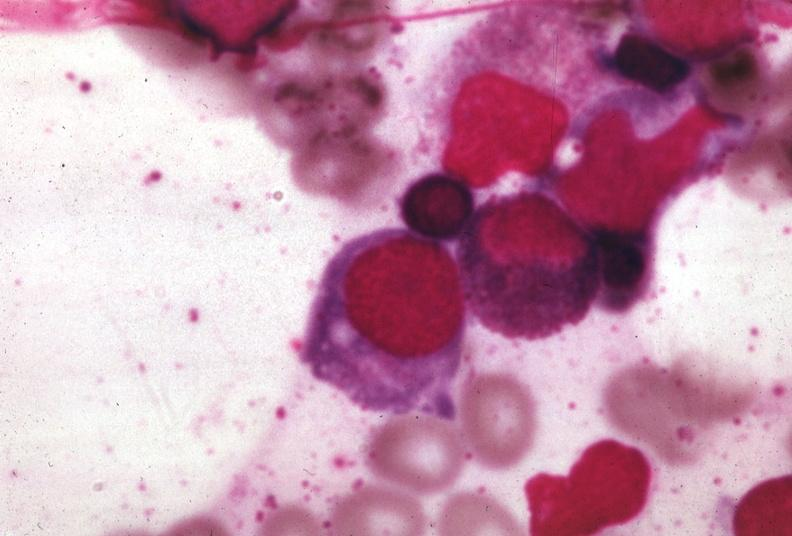what is present?
Answer the question using a single word or phrase. Megaloblasts pernicious anemia 